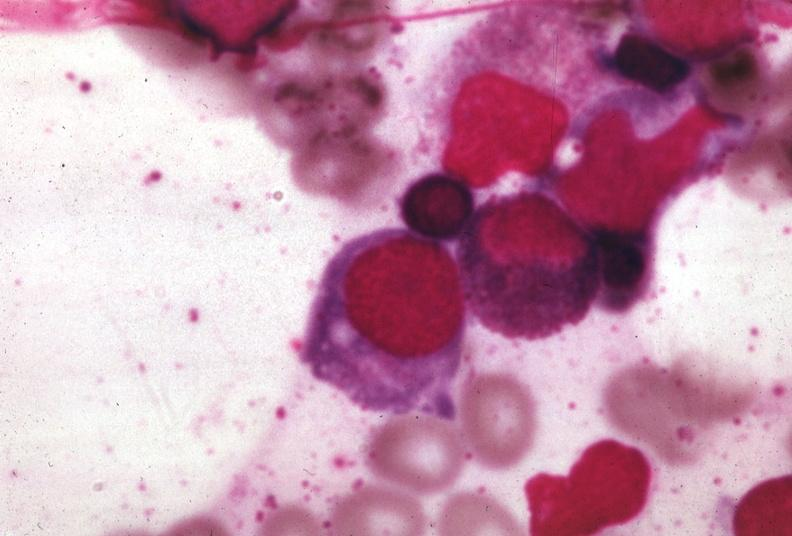what is present?
Answer the question using a single word or phrase. Megaloblasts pernicious anemia 